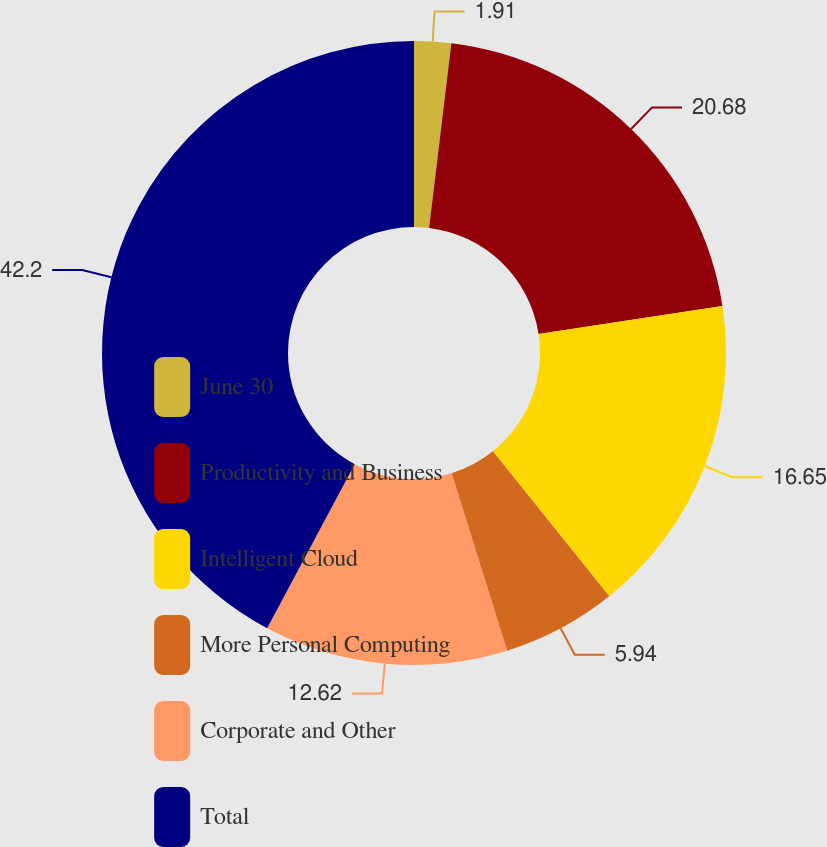Convert chart. <chart><loc_0><loc_0><loc_500><loc_500><pie_chart><fcel>June 30<fcel>Productivity and Business<fcel>Intelligent Cloud<fcel>More Personal Computing<fcel>Corporate and Other<fcel>Total<nl><fcel>1.91%<fcel>20.68%<fcel>16.65%<fcel>5.94%<fcel>12.62%<fcel>42.2%<nl></chart> 